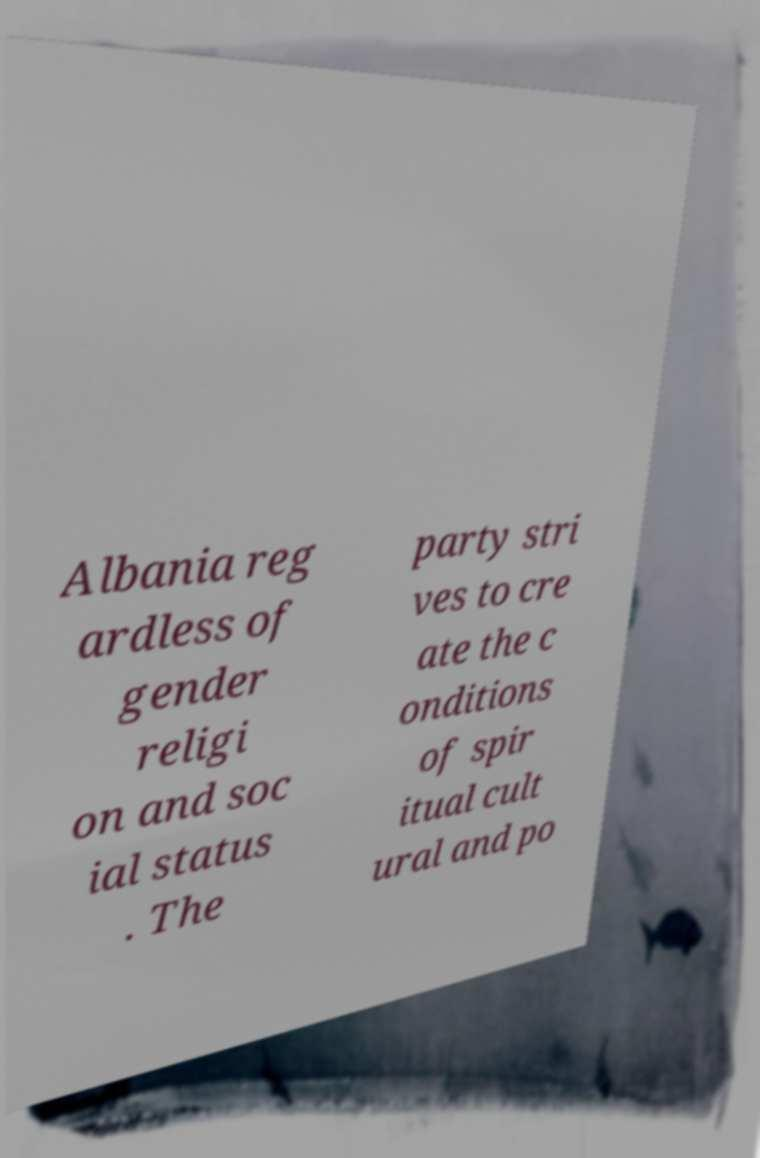Could you extract and type out the text from this image? Albania reg ardless of gender religi on and soc ial status . The party stri ves to cre ate the c onditions of spir itual cult ural and po 